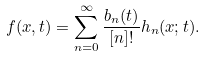Convert formula to latex. <formula><loc_0><loc_0><loc_500><loc_500>f ( x , t ) = \sum _ { n = 0 } ^ { \infty } \frac { b _ { n } ( t ) } { [ n ] ! } h _ { n } ( x ; t ) .</formula> 